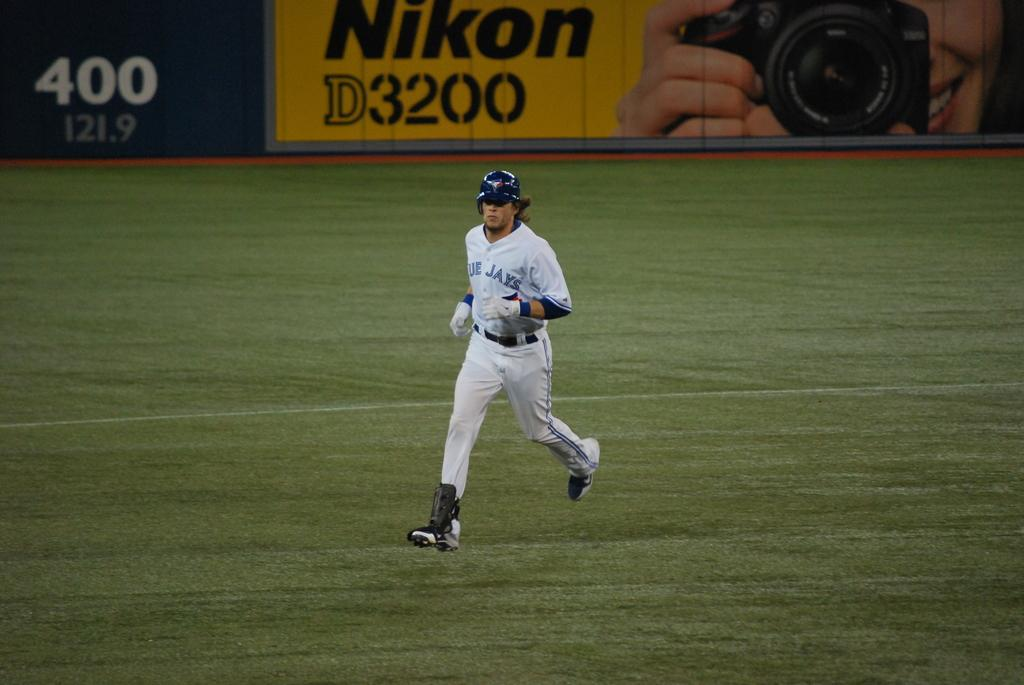<image>
Write a terse but informative summary of the picture. a man in a blue jays baseball uniform is running down a field. 